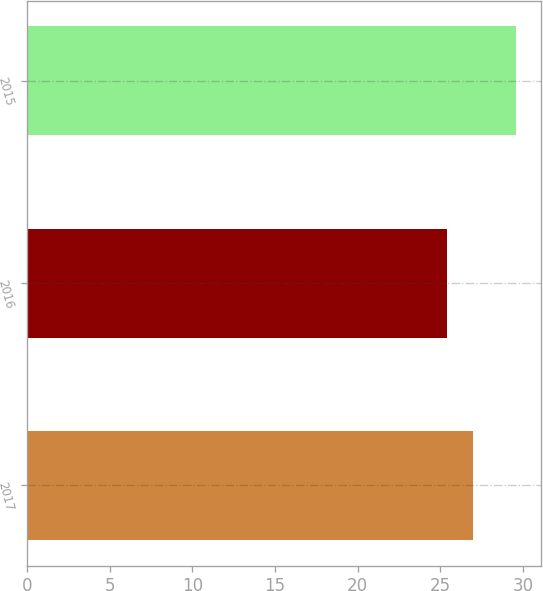<chart> <loc_0><loc_0><loc_500><loc_500><bar_chart><fcel>2017<fcel>2016<fcel>2015<nl><fcel>27<fcel>25.4<fcel>29.6<nl></chart> 